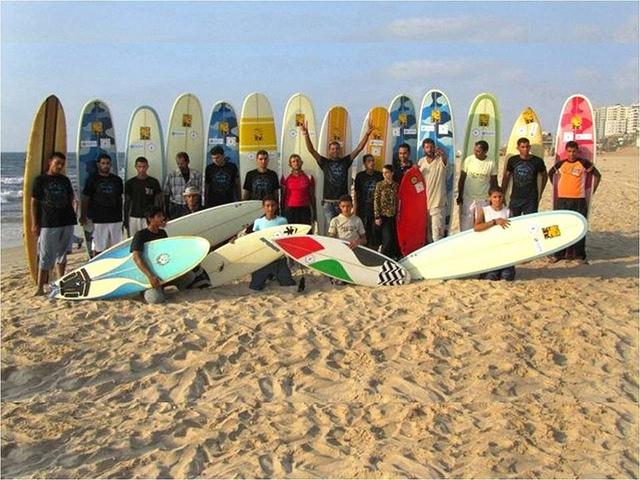What is the man in black shorts doing?
Short answer required. Standing. Are there buildings in the background?
Be succinct. Yes. How many surfboards on laying on the sand?
Answer briefly. 5. Is this a beach?
Write a very short answer. Yes. How many boards?
Be succinct. 19. How many surfboards are in this picture?
Write a very short answer. 19. 